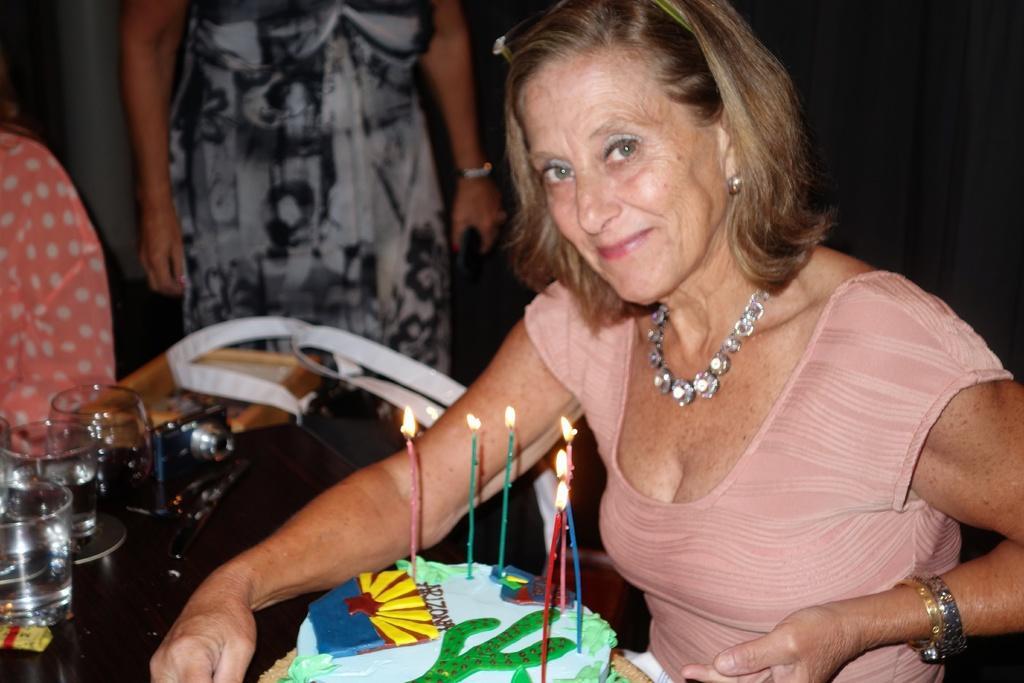How would you summarize this image in a sentence or two? In this image, at the right side there is a woman, she is sitting and she is holding a cake, there are some candles on the cake, there is a table on that table there are some glasses, at the background there is a woman standing. 